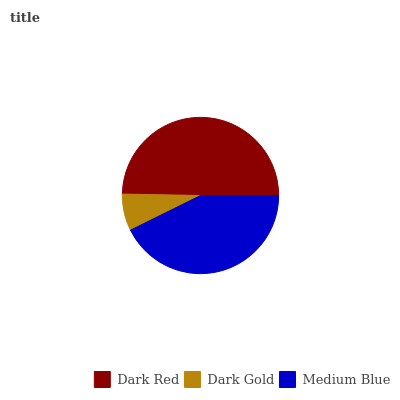Is Dark Gold the minimum?
Answer yes or no. Yes. Is Dark Red the maximum?
Answer yes or no. Yes. Is Medium Blue the minimum?
Answer yes or no. No. Is Medium Blue the maximum?
Answer yes or no. No. Is Medium Blue greater than Dark Gold?
Answer yes or no. Yes. Is Dark Gold less than Medium Blue?
Answer yes or no. Yes. Is Dark Gold greater than Medium Blue?
Answer yes or no. No. Is Medium Blue less than Dark Gold?
Answer yes or no. No. Is Medium Blue the high median?
Answer yes or no. Yes. Is Medium Blue the low median?
Answer yes or no. Yes. Is Dark Gold the high median?
Answer yes or no. No. Is Dark Gold the low median?
Answer yes or no. No. 